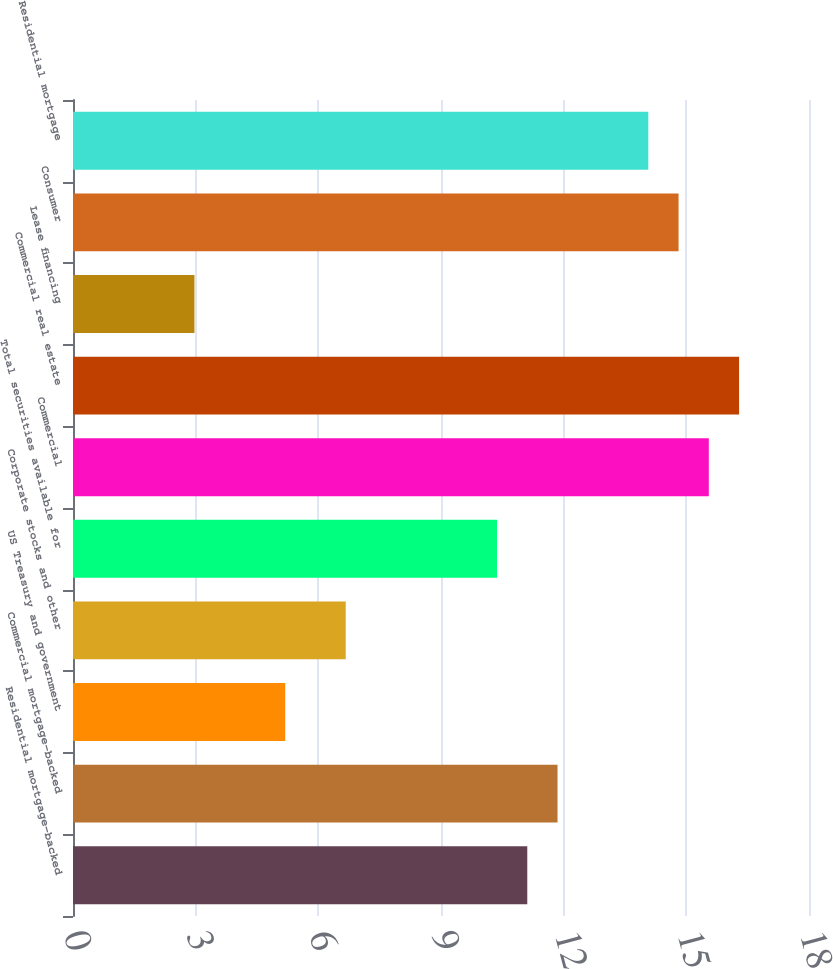<chart> <loc_0><loc_0><loc_500><loc_500><bar_chart><fcel>Residential mortgage-backed<fcel>Commercial mortgage-backed<fcel>US Treasury and government<fcel>Corporate stocks and other<fcel>Total securities available for<fcel>Commercial<fcel>Commercial real estate<fcel>Lease financing<fcel>Consumer<fcel>Residential mortgage<nl><fcel>11.11<fcel>11.85<fcel>5.19<fcel>6.67<fcel>10.37<fcel>15.55<fcel>16.29<fcel>2.97<fcel>14.81<fcel>14.07<nl></chart> 